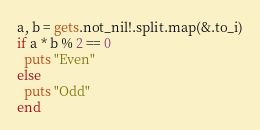Convert code to text. <code><loc_0><loc_0><loc_500><loc_500><_Crystal_>a, b = gets.not_nil!.split.map(&.to_i)
if a * b % 2 == 0
  puts "Even"
else
  puts "Odd"
end</code> 